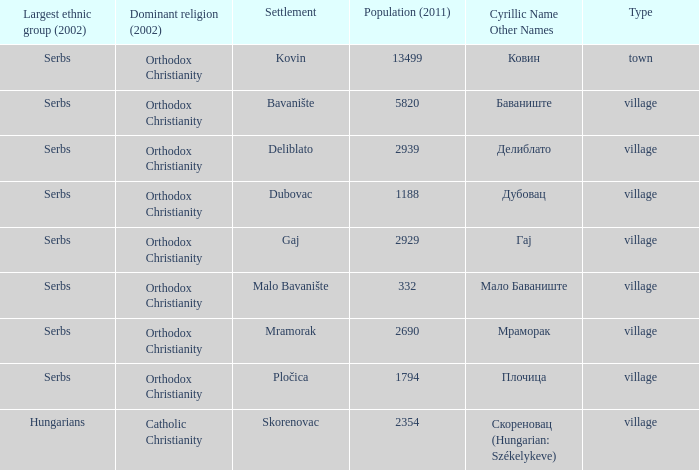What is the Deliblato village known as in Cyrillic? Делиблато. 